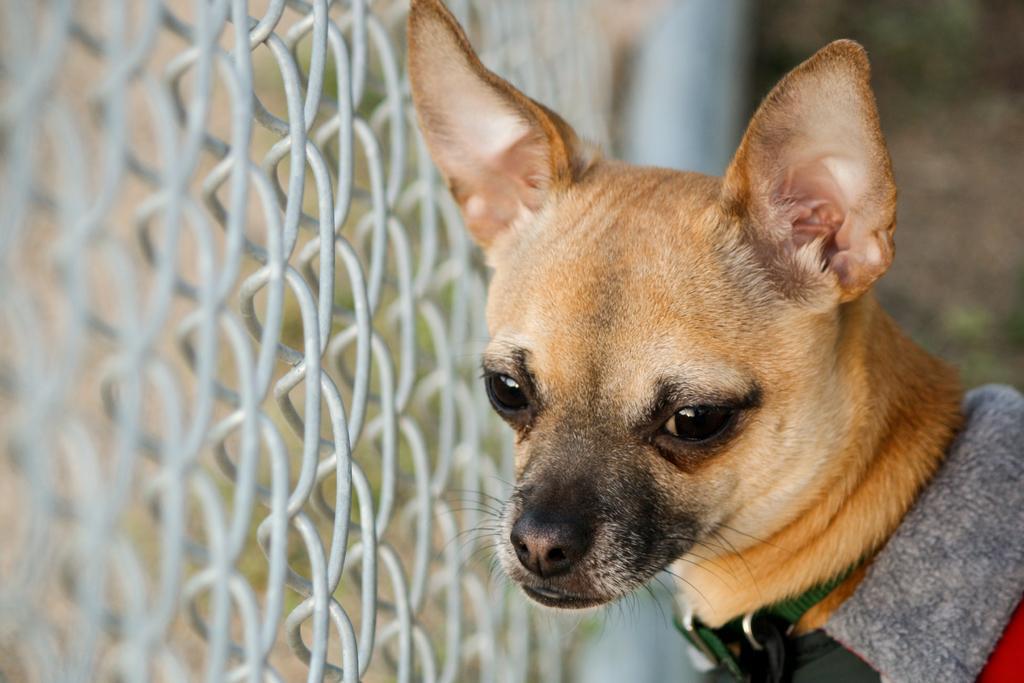Please provide a concise description of this image. In this image there is a dog. At left side of the image there is a fencing. 